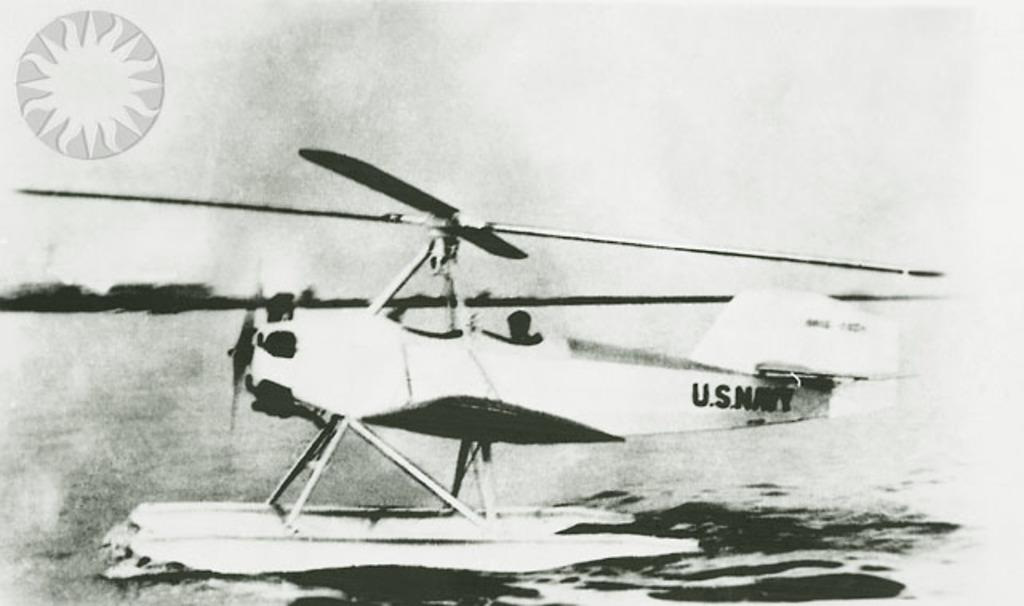<image>
Render a clear and concise summary of the photo. A U.S. Navy propeller plane with water skis is sitting on the water. 